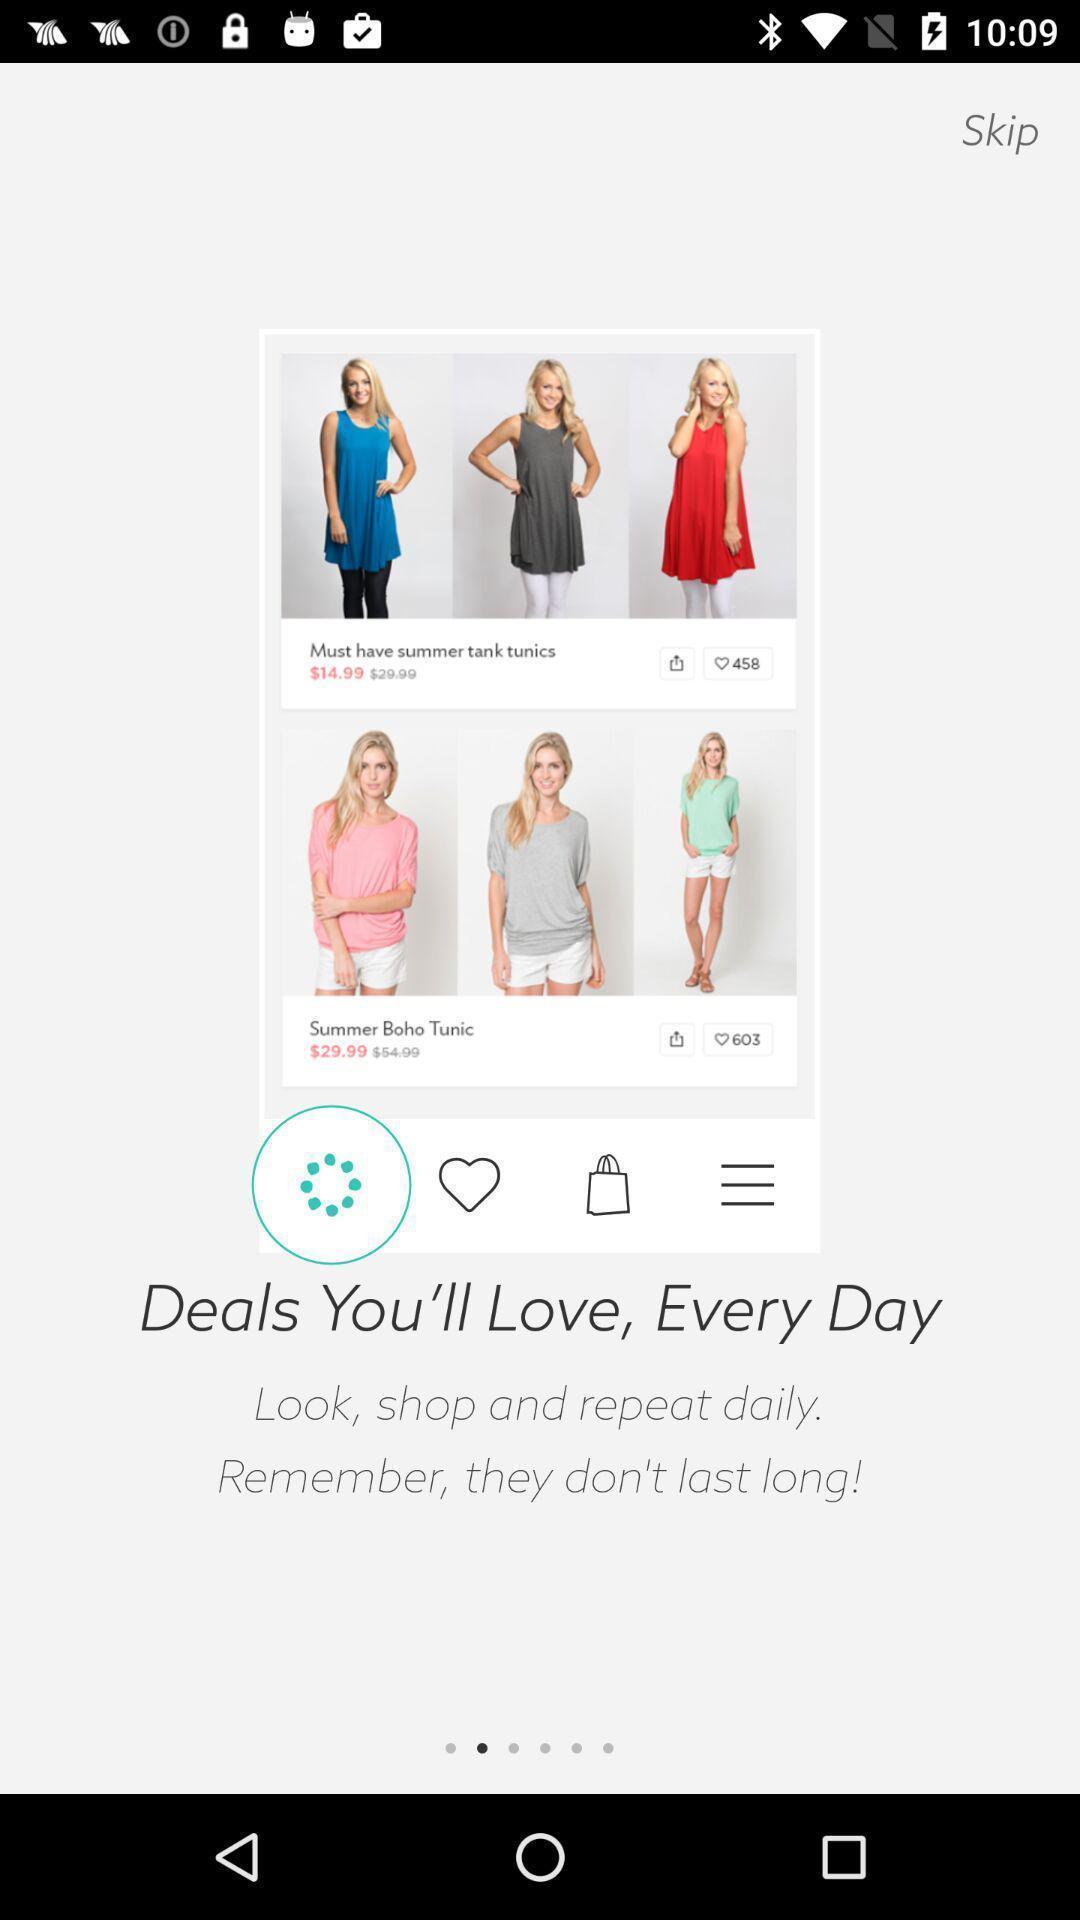Please provide a description for this image. Starting page of a shopping app. 